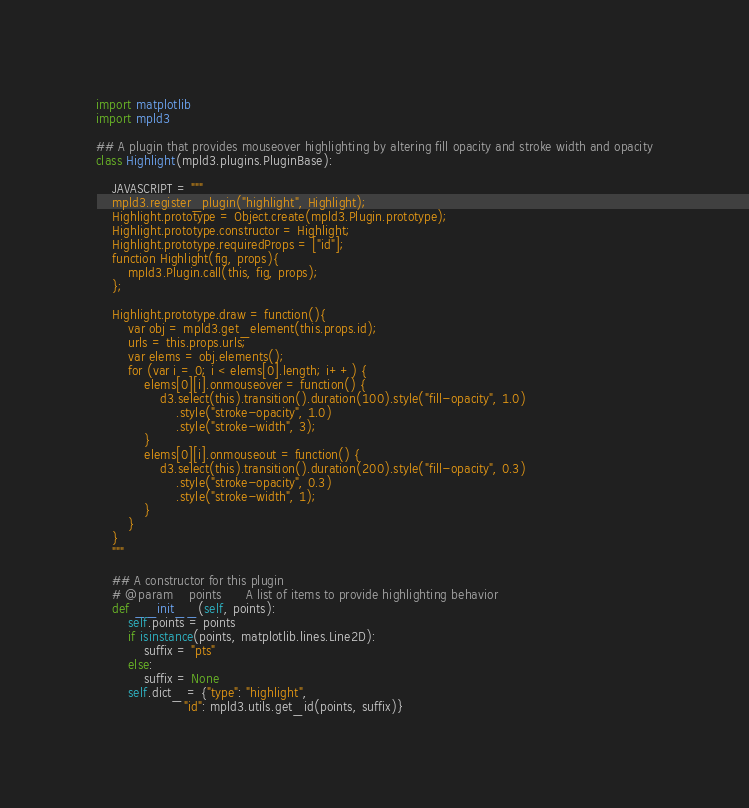<code> <loc_0><loc_0><loc_500><loc_500><_Python_>import matplotlib
import mpld3

## A plugin that provides mouseover highlighting by altering fill opacity and stroke width and opacity
class Highlight(mpld3.plugins.PluginBase):

    JAVASCRIPT = """
    mpld3.register_plugin("highlight", Highlight);
    Highlight.prototype = Object.create(mpld3.Plugin.prototype);
    Highlight.prototype.constructor = Highlight;
    Highlight.prototype.requiredProps = ["id"];
    function Highlight(fig, props){
        mpld3.Plugin.call(this, fig, props);
    };

    Highlight.prototype.draw = function(){
        var obj = mpld3.get_element(this.props.id);
        urls = this.props.urls;
        var elems = obj.elements();
        for (var i = 0; i < elems[0].length; i++) {
            elems[0][i].onmouseover = function() {
                d3.select(this).transition().duration(100).style("fill-opacity", 1.0)
                    .style("stroke-opacity", 1.0)
                    .style("stroke-width", 3);
            }
            elems[0][i].onmouseout = function() {
                d3.select(this).transition().duration(200).style("fill-opacity", 0.3)
                    .style("stroke-opacity", 0.3)
                    .style("stroke-width", 1);
            }
        }
    }
    """

    ## A constructor for this plugin
    # @param    points      A list of items to provide highlighting behavior
    def __init__(self, points):
        self.points = points
        if isinstance(points, matplotlib.lines.Line2D):
            suffix = "pts"
        else:
            suffix = None
        self.dict_ = {"type": "highlight",
                      "id": mpld3.utils.get_id(points, suffix)}</code> 